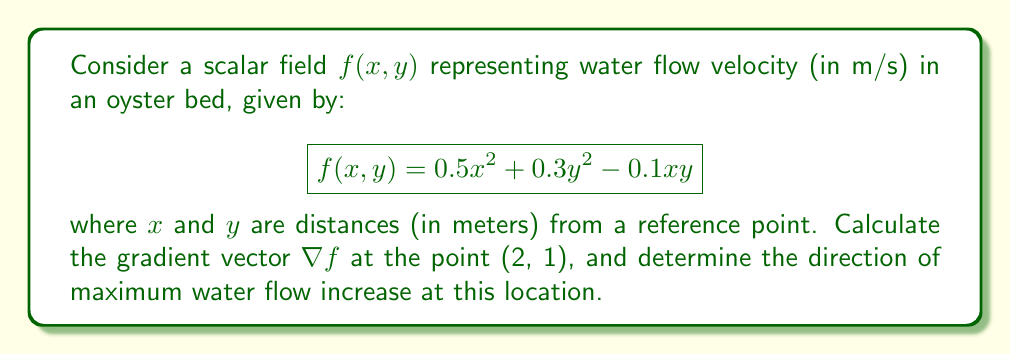Give your solution to this math problem. 1) The gradient of a scalar field $f(x,y)$ is given by:

   $$\nabla f = \left(\frac{\partial f}{\partial x}, \frac{\partial f}{\partial y}\right)$$

2) Calculate partial derivatives:
   
   $$\frac{\partial f}{\partial x} = x - 0.1y$$
   $$\frac{\partial f}{\partial y} = 0.6y - 0.1x$$

3) Evaluate the gradient at the point (2, 1):
   
   $$\nabla f(2,1) = (2 - 0.1(1), 0.6(1) - 0.1(2))$$
   $$\nabla f(2,1) = (1.9, 0.4)$$

4) The gradient vector points in the direction of maximum increase. To find the direction, we need to normalize the vector:

   $$\text{magnitude} = \sqrt{1.9^2 + 0.4^2} = \sqrt{3.77} \approx 1.94$$

   $$\text{unit vector} = \frac{(1.9, 0.4)}{1.94} \approx (0.98, 0.21)$$

5) Convert to polar coordinates for direction:
   
   $$\theta = \tan^{-1}\left(\frac{0.21}{0.98}\right) \approx 0.21 \text{ radians} \approx 12.1°$$

This angle is measured counterclockwise from the positive x-axis.
Answer: $\nabla f(2,1) = (1.9, 0.4)$; direction ≈ 12.1° from positive x-axis 